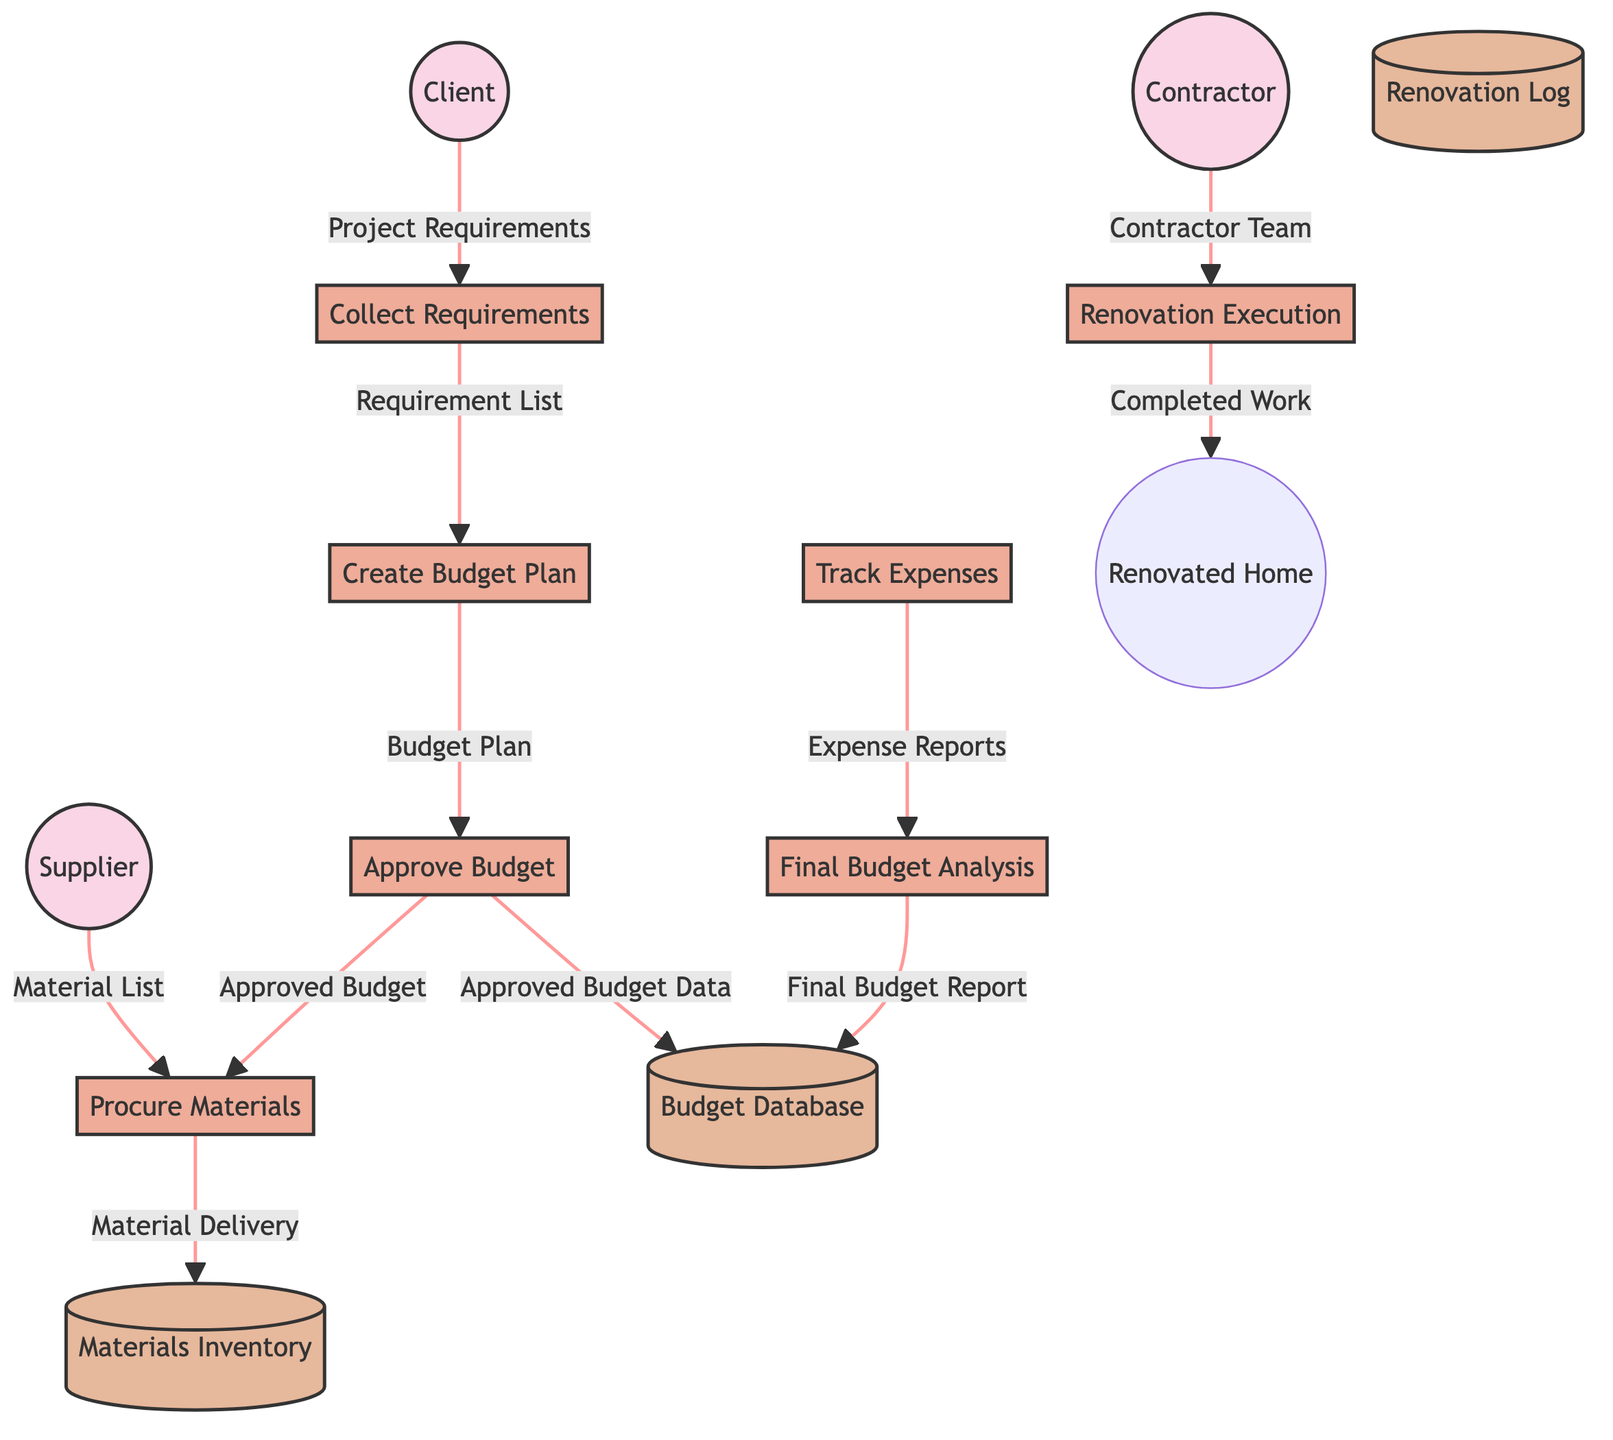What is the role of the Client in this diagram? The Client is an external entity responsible for providing project requirements to the process of Collect Requirements.
Answer: Homeowner What is the output of the process named Approve Budget? The output of the Approve Budget process is the Approved Budget, which is what allows subsequent processes to proceed based on the client's approval.
Answer: Approved Budget How many processes are depicted in the diagram? The diagram shows seven distinct processes that handle different stages of the renovation project budgeting workflow.
Answer: Seven What does the Renovation Execution process require as an input? The Renovation Execution process requires three inputs: the Approved Budget, the Material Delivery, and the Contractor.
Answer: Approved Budget, Material Delivery, Contractor What is stored in the Budget Database? The Budget Database stores all budget plans, approvals, and expense reports generated throughout the renovation project.
Answer: Budget plans, approvals, expense reports Which external entity provides the Material List? The Supplier is the external entity that supplies the Material List needed during the Procure Materials process.
Answer: Supplier What is the final output of the budgeting analysis? The final output of the Final Budget Analysis process is the Final Budget Report, which summarizes the costs in relation to the initial budget.
Answer: Final Budget Report Which process comes immediately after Create Budget Plan? After Create Budget Plan, the process that follows is Approve Budget, which requires the client to approve the budget developed from the project's requirements.
Answer: Approve Budget How are the Approved Budget Data recorded? The Approved Budget Data is recorded in the Budget Database after the budget has been approved by the client.
Answer: Budget Database 